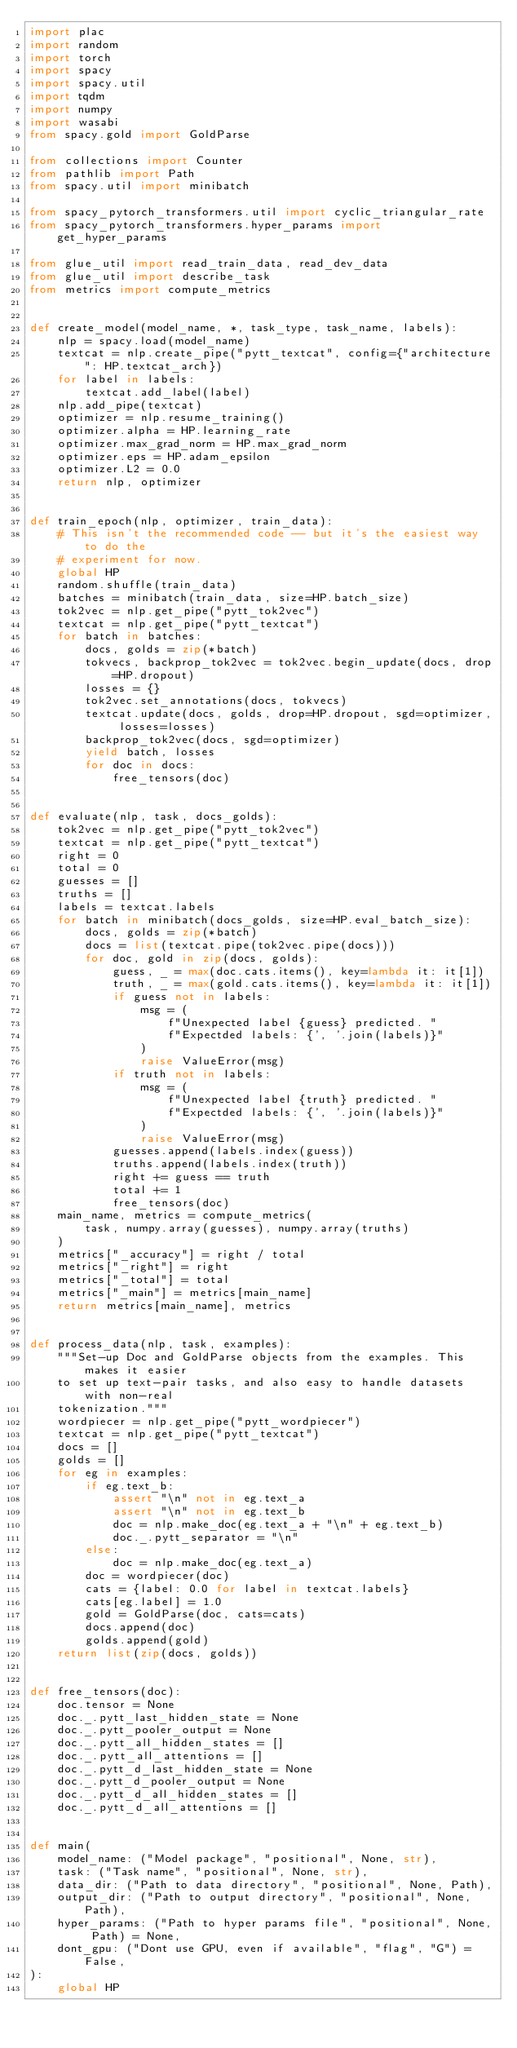Convert code to text. <code><loc_0><loc_0><loc_500><loc_500><_Python_>import plac
import random
import torch
import spacy
import spacy.util
import tqdm
import numpy
import wasabi
from spacy.gold import GoldParse

from collections import Counter
from pathlib import Path
from spacy.util import minibatch

from spacy_pytorch_transformers.util import cyclic_triangular_rate
from spacy_pytorch_transformers.hyper_params import get_hyper_params

from glue_util import read_train_data, read_dev_data
from glue_util import describe_task
from metrics import compute_metrics


def create_model(model_name, *, task_type, task_name, labels):
    nlp = spacy.load(model_name)
    textcat = nlp.create_pipe("pytt_textcat", config={"architecture": HP.textcat_arch})
    for label in labels:
        textcat.add_label(label)
    nlp.add_pipe(textcat)
    optimizer = nlp.resume_training()
    optimizer.alpha = HP.learning_rate
    optimizer.max_grad_norm = HP.max_grad_norm
    optimizer.eps = HP.adam_epsilon
    optimizer.L2 = 0.0
    return nlp, optimizer


def train_epoch(nlp, optimizer, train_data):
    # This isn't the recommended code -- but it's the easiest way to do the
    # experiment for now.
    global HP
    random.shuffle(train_data)
    batches = minibatch(train_data, size=HP.batch_size)
    tok2vec = nlp.get_pipe("pytt_tok2vec")
    textcat = nlp.get_pipe("pytt_textcat")
    for batch in batches:
        docs, golds = zip(*batch)
        tokvecs, backprop_tok2vec = tok2vec.begin_update(docs, drop=HP.dropout)
        losses = {}
        tok2vec.set_annotations(docs, tokvecs)
        textcat.update(docs, golds, drop=HP.dropout, sgd=optimizer, losses=losses)
        backprop_tok2vec(docs, sgd=optimizer)
        yield batch, losses
        for doc in docs:
            free_tensors(doc)


def evaluate(nlp, task, docs_golds):
    tok2vec = nlp.get_pipe("pytt_tok2vec")
    textcat = nlp.get_pipe("pytt_textcat")
    right = 0
    total = 0
    guesses = []
    truths = []
    labels = textcat.labels
    for batch in minibatch(docs_golds, size=HP.eval_batch_size):
        docs, golds = zip(*batch)
        docs = list(textcat.pipe(tok2vec.pipe(docs)))
        for doc, gold in zip(docs, golds):
            guess, _ = max(doc.cats.items(), key=lambda it: it[1])
            truth, _ = max(gold.cats.items(), key=lambda it: it[1])
            if guess not in labels:
                msg = (
                    f"Unexpected label {guess} predicted. "
                    f"Expectded labels: {', '.join(labels)}"
                )
                raise ValueError(msg)
            if truth not in labels:
                msg = (
                    f"Unexpected label {truth} predicted. "
                    f"Expectded labels: {', '.join(labels)}"
                )
                raise ValueError(msg)
            guesses.append(labels.index(guess))
            truths.append(labels.index(truth))
            right += guess == truth
            total += 1
            free_tensors(doc)
    main_name, metrics = compute_metrics(
        task, numpy.array(guesses), numpy.array(truths)
    )
    metrics["_accuracy"] = right / total
    metrics["_right"] = right
    metrics["_total"] = total
    metrics["_main"] = metrics[main_name]
    return metrics[main_name], metrics


def process_data(nlp, task, examples):
    """Set-up Doc and GoldParse objects from the examples. This makes it easier
    to set up text-pair tasks, and also easy to handle datasets with non-real
    tokenization."""
    wordpiecer = nlp.get_pipe("pytt_wordpiecer")
    textcat = nlp.get_pipe("pytt_textcat")
    docs = []
    golds = []
    for eg in examples:
        if eg.text_b:
            assert "\n" not in eg.text_a
            assert "\n" not in eg.text_b
            doc = nlp.make_doc(eg.text_a + "\n" + eg.text_b)
            doc._.pytt_separator = "\n"
        else:
            doc = nlp.make_doc(eg.text_a)
        doc = wordpiecer(doc)
        cats = {label: 0.0 for label in textcat.labels}
        cats[eg.label] = 1.0
        gold = GoldParse(doc, cats=cats)
        docs.append(doc)
        golds.append(gold)
    return list(zip(docs, golds))


def free_tensors(doc):
    doc.tensor = None
    doc._.pytt_last_hidden_state = None
    doc._.pytt_pooler_output = None
    doc._.pytt_all_hidden_states = []
    doc._.pytt_all_attentions = []
    doc._.pytt_d_last_hidden_state = None
    doc._.pytt_d_pooler_output = None
    doc._.pytt_d_all_hidden_states = []
    doc._.pytt_d_all_attentions = []


def main(
    model_name: ("Model package", "positional", None, str),
    task: ("Task name", "positional", None, str),
    data_dir: ("Path to data directory", "positional", None, Path),
    output_dir: ("Path to output directory", "positional", None, Path),
    hyper_params: ("Path to hyper params file", "positional", None, Path) = None,
    dont_gpu: ("Dont use GPU, even if available", "flag", "G") = False,
):
    global HP</code> 